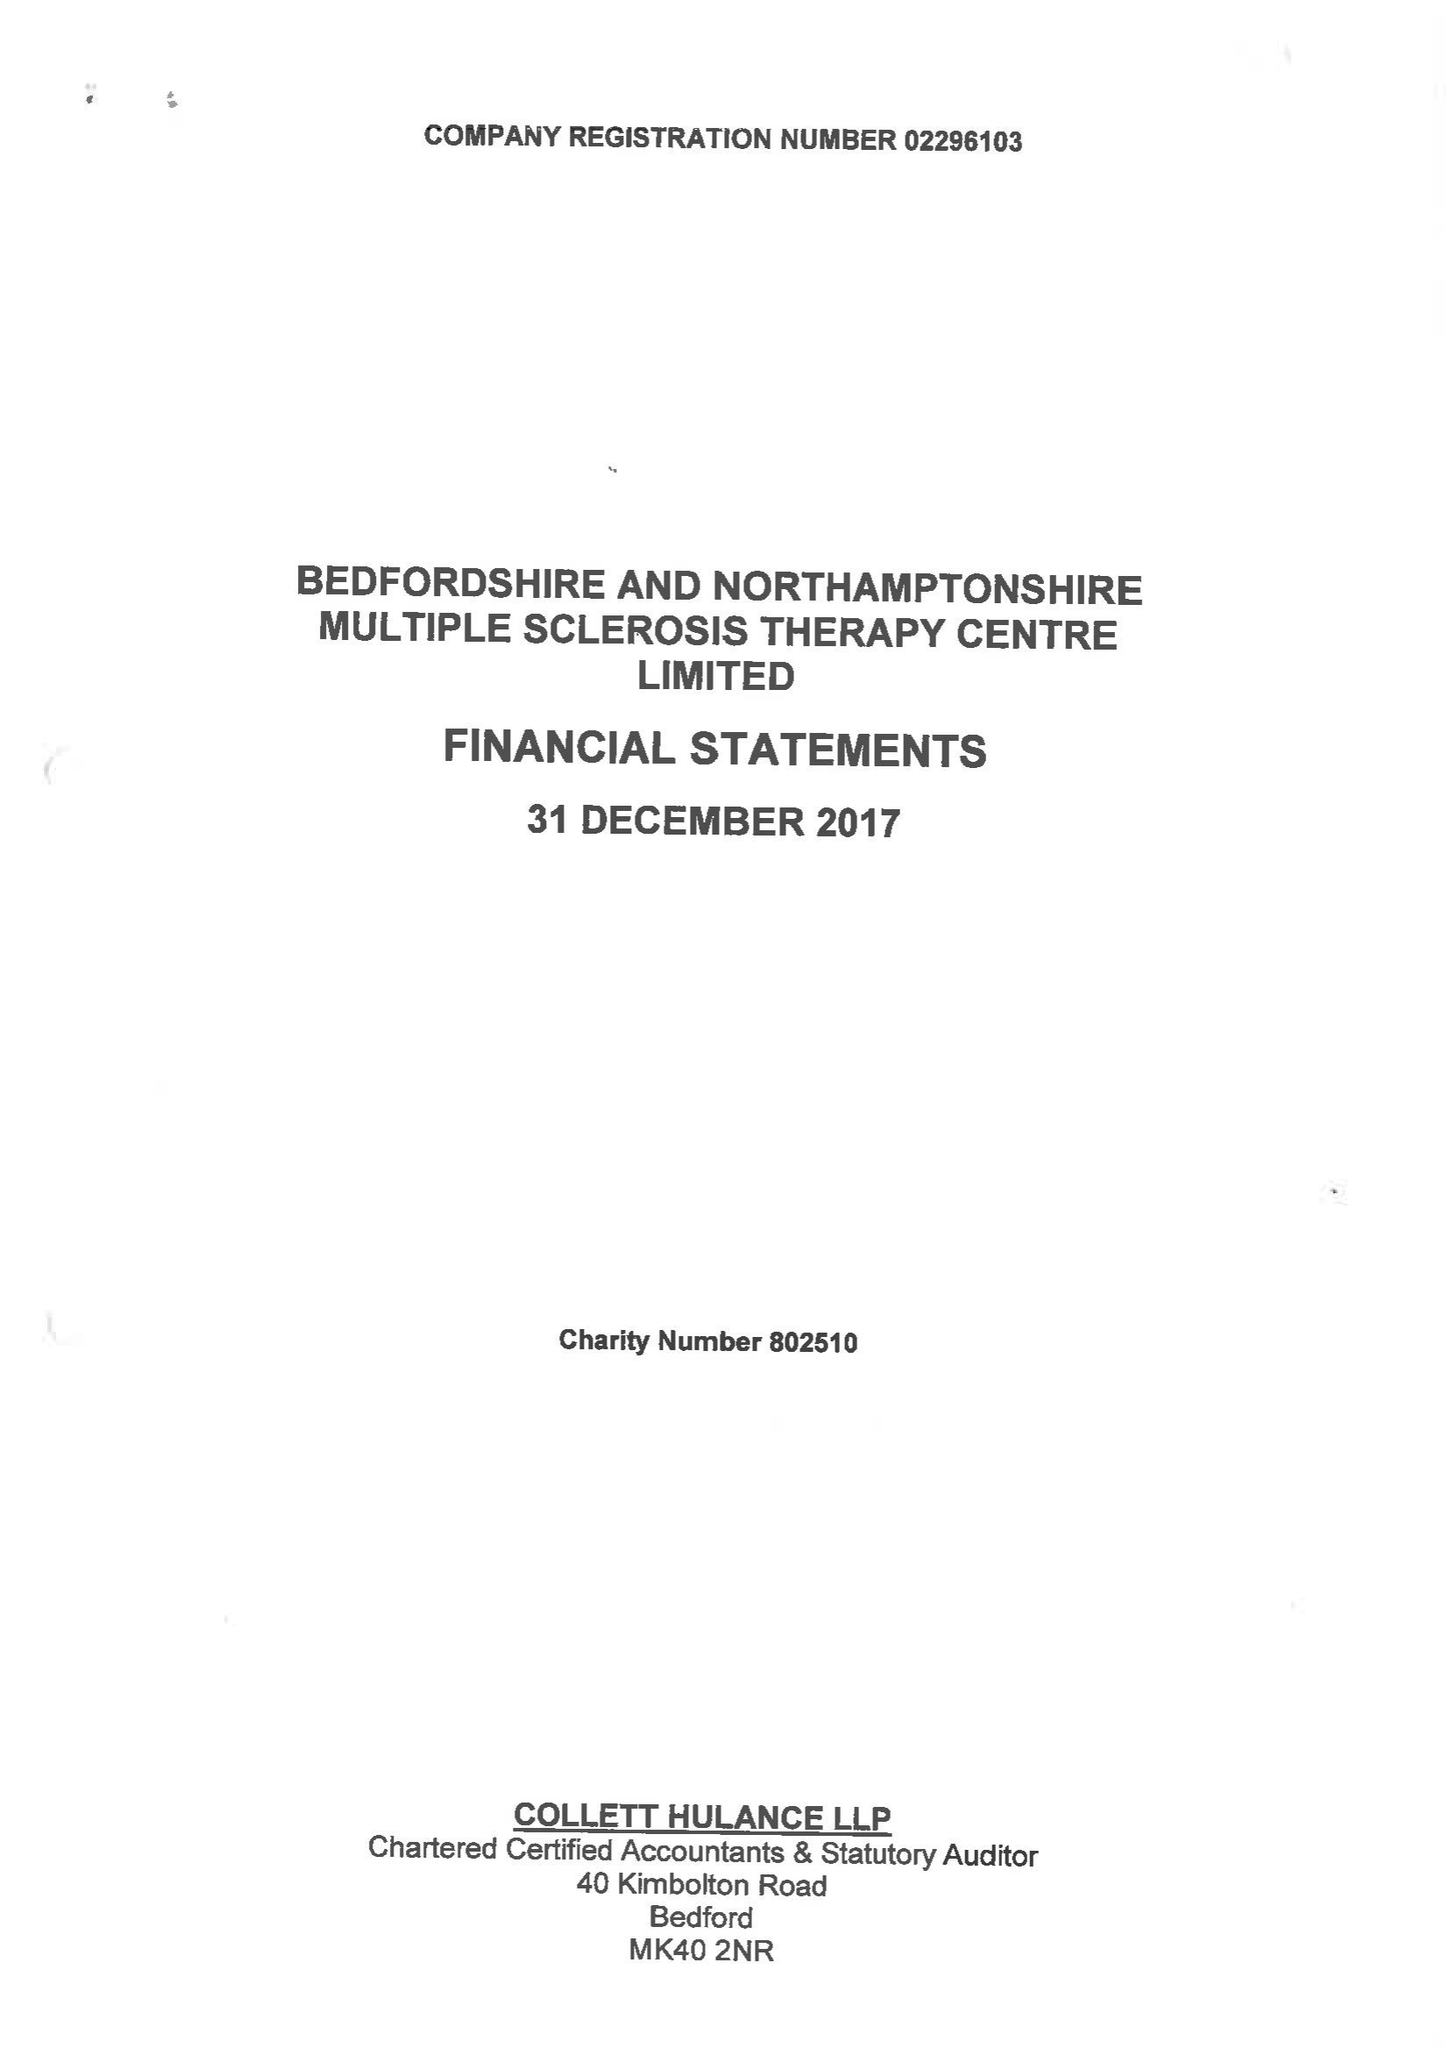What is the value for the spending_annually_in_british_pounds?
Answer the question using a single word or phrase. 388752.00 